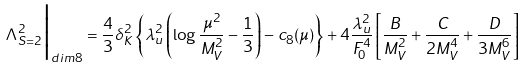<formula> <loc_0><loc_0><loc_500><loc_500>\Lambda ^ { 2 } _ { S = 2 } \Big | _ { d i m 8 } = \frac { 4 } { 3 } \delta _ { K } ^ { 2 } \left \{ \lambda _ { u } ^ { 2 } \left ( \log \frac { \mu ^ { 2 } } { M _ { V } ^ { 2 } } - \frac { 1 } { 3 } \right ) - c _ { 8 } ( \mu ) \right \} + 4 \frac { \lambda _ { u } ^ { 2 } } { F _ { 0 } ^ { 4 } } \left [ \frac { B } { M _ { V } ^ { 2 } } + \frac { C } { 2 M _ { V } ^ { 4 } } + \frac { D } { 3 M _ { V } ^ { 6 } } \right ]</formula> 